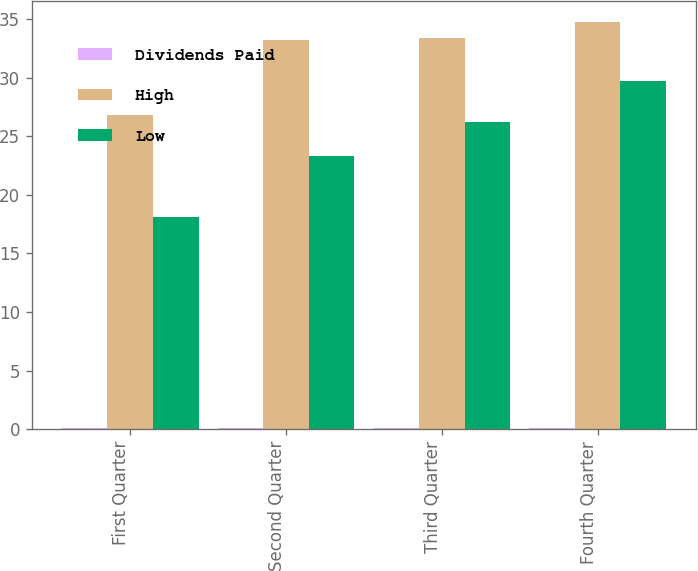<chart> <loc_0><loc_0><loc_500><loc_500><stacked_bar_chart><ecel><fcel>First Quarter<fcel>Second Quarter<fcel>Third Quarter<fcel>Fourth Quarter<nl><fcel>Dividends Paid<fcel>0.11<fcel>0.11<fcel>0.11<fcel>0.11<nl><fcel>High<fcel>26.81<fcel>33.2<fcel>33.41<fcel>34.78<nl><fcel>Low<fcel>18.14<fcel>23.27<fcel>26.23<fcel>29.73<nl></chart> 